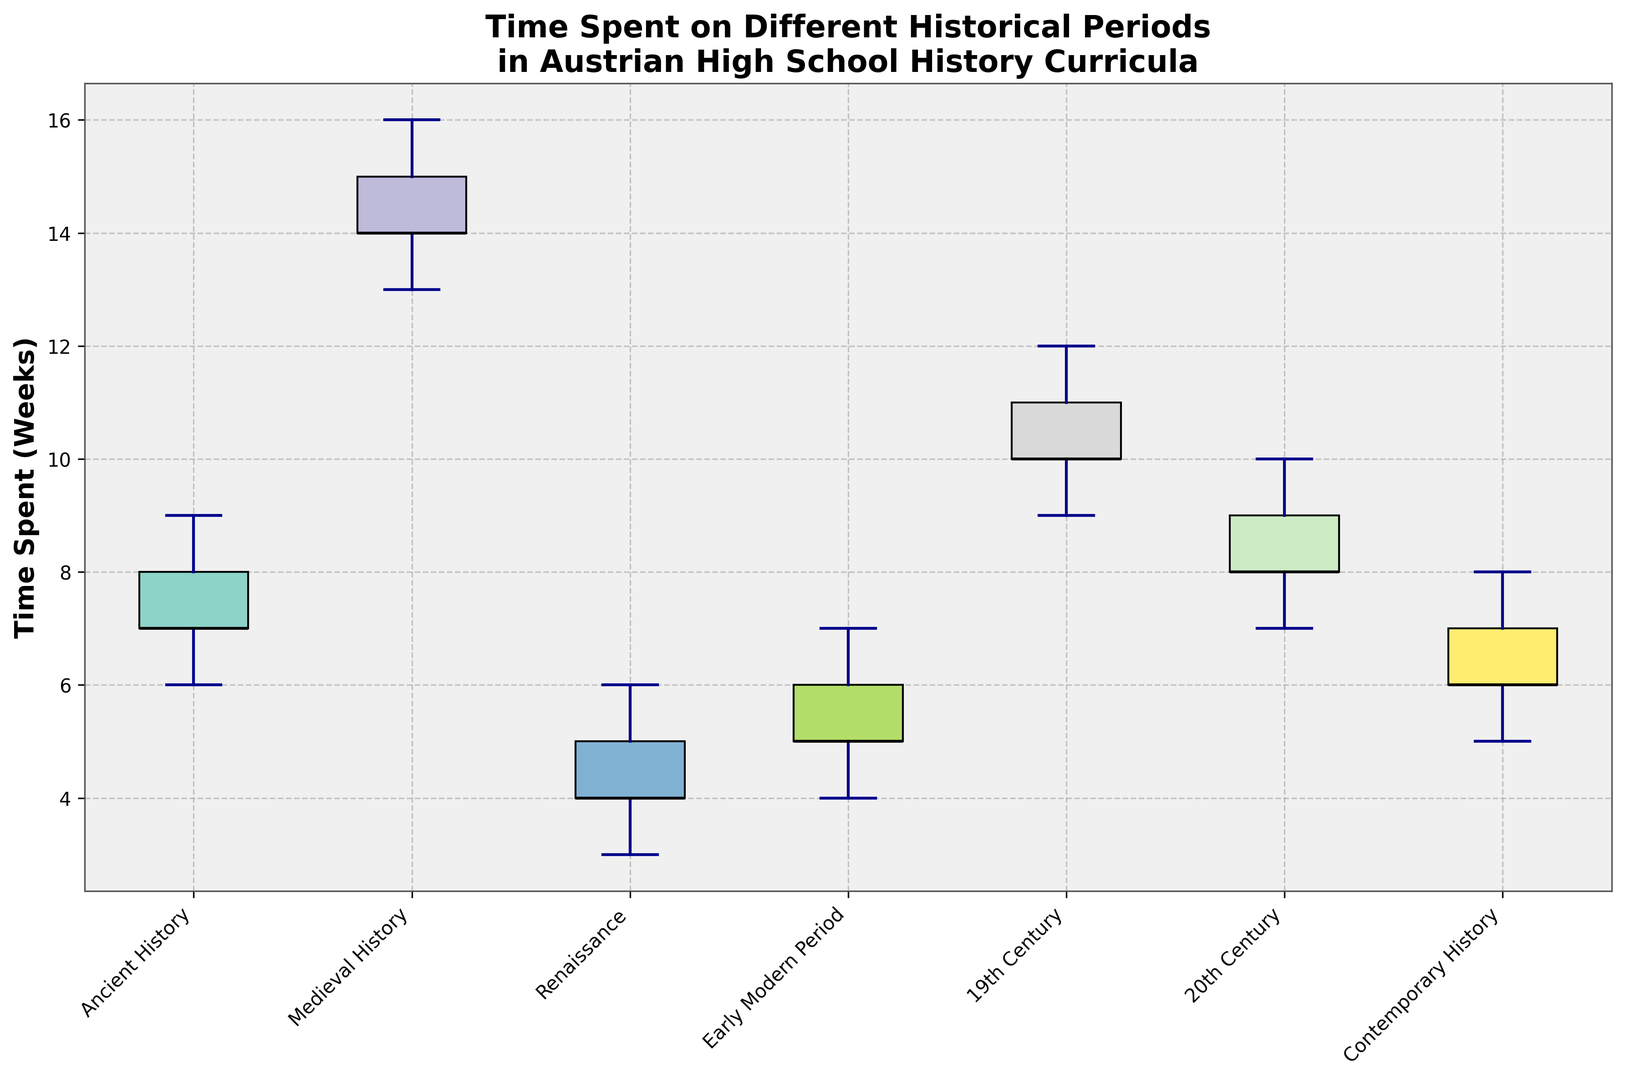How much time is typically spent on Ancient History in the curriculum? The figure shows the distribution of time spent on Ancient History, represented by the boxplot for that period. The median line inside the box represents the median value. Estimate the median value from the figure.
Answer: 4 weeks Which historical period has the widest range of time spent? To determine the widest range, look for the period with the longest whiskers in the boxplot since the whiskers indicate the range from the minimum to the maximum value.
Answer: 20th Century Compare the median time spent on the 19th Century with Modern History (20th Century). Which one has a higher median? Find the median lines inside the boxes for both periods. Compare their height to see which is higher.
Answer: 20th Century Which period has the lowest median time spent? Look at the median lines inside each box and find the one that is the lowest.
Answer: Ancient History By comparing median values, how much more time is spent on the Early Modern Period compared to Contemporary History? Identify and compare the median lines for both periods. Subtract Contemporary History's median from the Early Modern Period's median.
Answer: 5 weeks Is the time spent on Medieval History more consistent than the time spent on Contemporary History? Consistency can be judged by the interquartile range (IQR), the length of the box. Compare the lengths of the boxes for Medieval and Contemporary History.
Answer: No How does the interquartile range (IQR) of Renaissance compare with Ancient History? Which is larger? IQR is the length of the box. Compare the length of the boxes for Renaissance and Ancient History.
Answer: Renaissance Which historical period has the least consistent time spent, based on the length of the whiskers? The period with the longest total whiskers from the minimum to maximum values is the least consistent.
Answer: 20th Century What can you infer about the variance in time spent on the Renaissance period? Variance can be inferred from the length of the whiskers and the size of the box. Shorter whiskers and smaller boxes indicate lower variance.
Answer: Low variance 